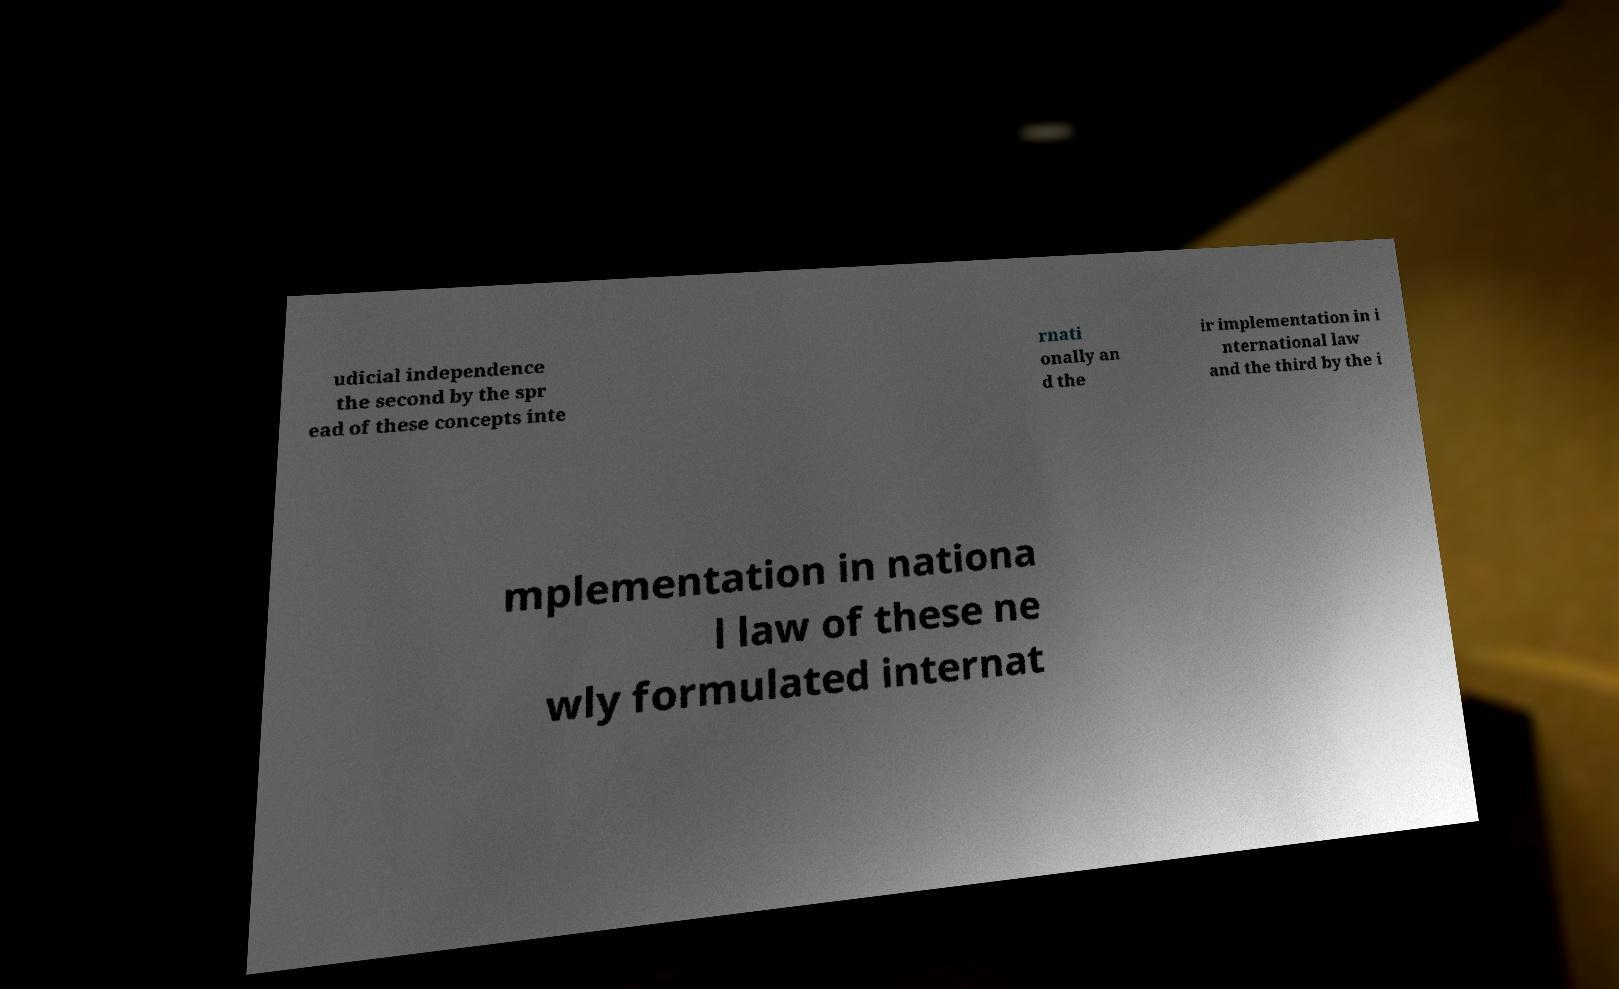What messages or text are displayed in this image? I need them in a readable, typed format. udicial independence the second by the spr ead of these concepts inte rnati onally an d the ir implementation in i nternational law and the third by the i mplementation in nationa l law of these ne wly formulated internat 